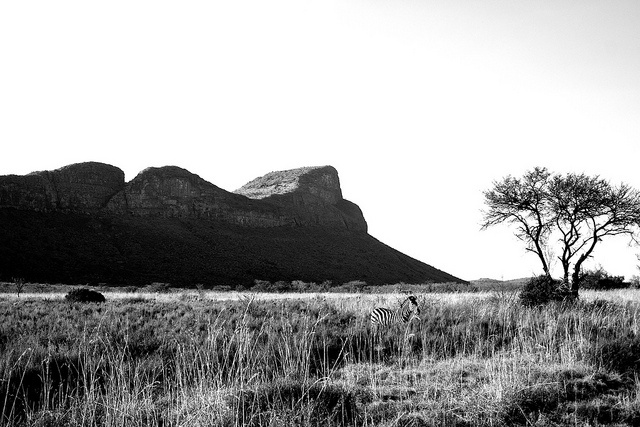Describe the objects in this image and their specific colors. I can see a zebra in white, gray, darkgray, black, and lightgray tones in this image. 